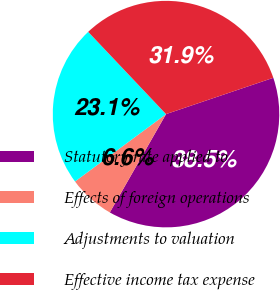Convert chart to OTSL. <chart><loc_0><loc_0><loc_500><loc_500><pie_chart><fcel>Statutory rate applied to<fcel>Effects of foreign operations<fcel>Adjustments to valuation<fcel>Effective income tax expense<nl><fcel>38.46%<fcel>6.59%<fcel>23.08%<fcel>31.87%<nl></chart> 